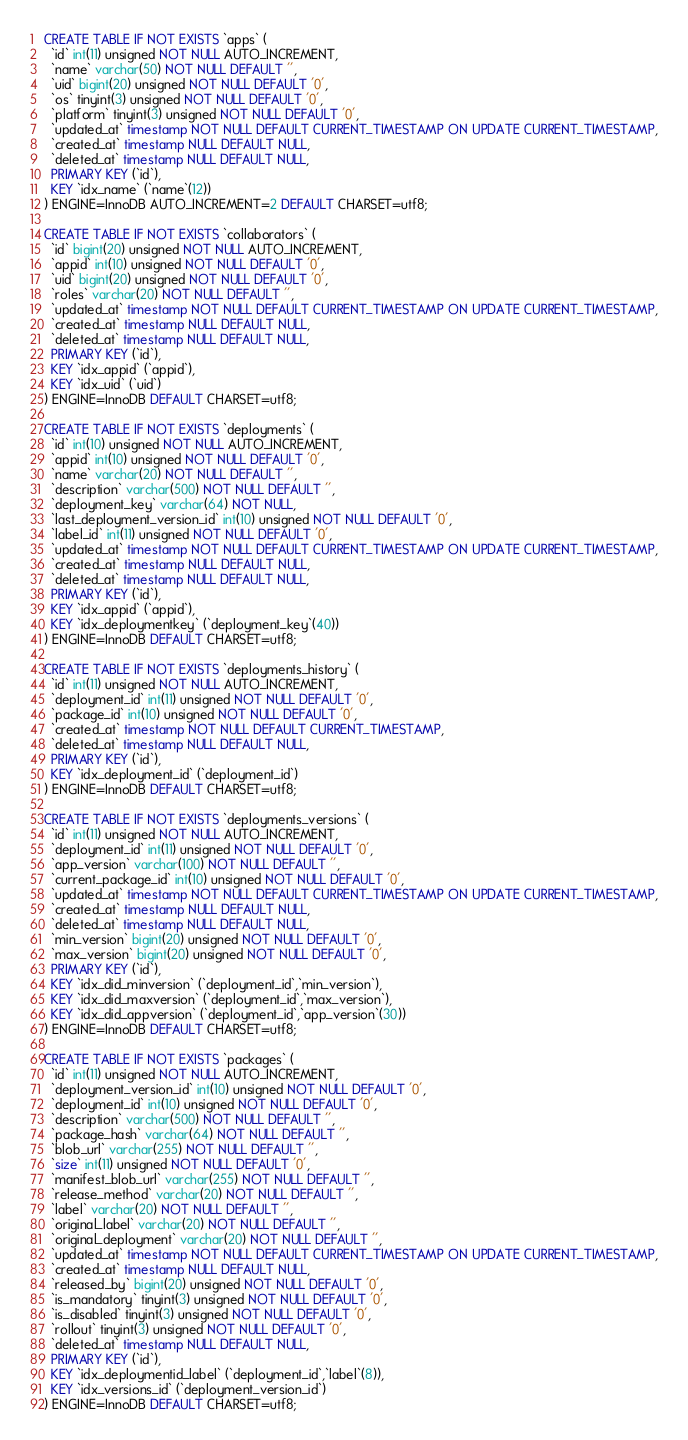Convert code to text. <code><loc_0><loc_0><loc_500><loc_500><_SQL_>CREATE TABLE IF NOT EXISTS `apps` (
  `id` int(11) unsigned NOT NULL AUTO_INCREMENT,
  `name` varchar(50) NOT NULL DEFAULT '',
  `uid` bigint(20) unsigned NOT NULL DEFAULT '0',
  `os` tinyint(3) unsigned NOT NULL DEFAULT '0',
  `platform` tinyint(3) unsigned NOT NULL DEFAULT '0',
  `updated_at` timestamp NOT NULL DEFAULT CURRENT_TIMESTAMP ON UPDATE CURRENT_TIMESTAMP,
  `created_at` timestamp NULL DEFAULT NULL,
  `deleted_at` timestamp NULL DEFAULT NULL,
  PRIMARY KEY (`id`),
  KEY `idx_name` (`name`(12))
) ENGINE=InnoDB AUTO_INCREMENT=2 DEFAULT CHARSET=utf8;

CREATE TABLE IF NOT EXISTS `collaborators` (
  `id` bigint(20) unsigned NOT NULL AUTO_INCREMENT,
  `appid` int(10) unsigned NOT NULL DEFAULT '0',
  `uid` bigint(20) unsigned NOT NULL DEFAULT '0',
  `roles` varchar(20) NOT NULL DEFAULT '',
  `updated_at` timestamp NOT NULL DEFAULT CURRENT_TIMESTAMP ON UPDATE CURRENT_TIMESTAMP,
  `created_at` timestamp NULL DEFAULT NULL,
  `deleted_at` timestamp NULL DEFAULT NULL,
  PRIMARY KEY (`id`),
  KEY `idx_appid` (`appid`),
  KEY `idx_uid` (`uid`)
) ENGINE=InnoDB DEFAULT CHARSET=utf8;

CREATE TABLE IF NOT EXISTS `deployments` (
  `id` int(10) unsigned NOT NULL AUTO_INCREMENT,
  `appid` int(10) unsigned NOT NULL DEFAULT '0',
  `name` varchar(20) NOT NULL DEFAULT '',
  `description` varchar(500) NOT NULL DEFAULT '',
  `deployment_key` varchar(64) NOT NULL,
  `last_deployment_version_id` int(10) unsigned NOT NULL DEFAULT '0',
  `label_id` int(11) unsigned NOT NULL DEFAULT '0',
  `updated_at` timestamp NOT NULL DEFAULT CURRENT_TIMESTAMP ON UPDATE CURRENT_TIMESTAMP,
  `created_at` timestamp NULL DEFAULT NULL,
  `deleted_at` timestamp NULL DEFAULT NULL,
  PRIMARY KEY (`id`),
  KEY `idx_appid` (`appid`),
  KEY `idx_deploymentkey` (`deployment_key`(40))
) ENGINE=InnoDB DEFAULT CHARSET=utf8;

CREATE TABLE IF NOT EXISTS `deployments_history` (
  `id` int(11) unsigned NOT NULL AUTO_INCREMENT,
  `deployment_id` int(11) unsigned NOT NULL DEFAULT '0',
  `package_id` int(10) unsigned NOT NULL DEFAULT '0',
  `created_at` timestamp NOT NULL DEFAULT CURRENT_TIMESTAMP,
  `deleted_at` timestamp NULL DEFAULT NULL,
  PRIMARY KEY (`id`),
  KEY `idx_deployment_id` (`deployment_id`)
) ENGINE=InnoDB DEFAULT CHARSET=utf8;

CREATE TABLE IF NOT EXISTS `deployments_versions` (
  `id` int(11) unsigned NOT NULL AUTO_INCREMENT,
  `deployment_id` int(11) unsigned NOT NULL DEFAULT '0',
  `app_version` varchar(100) NOT NULL DEFAULT '',
  `current_package_id` int(10) unsigned NOT NULL DEFAULT '0',
  `updated_at` timestamp NOT NULL DEFAULT CURRENT_TIMESTAMP ON UPDATE CURRENT_TIMESTAMP,
  `created_at` timestamp NULL DEFAULT NULL,
  `deleted_at` timestamp NULL DEFAULT NULL,
  `min_version` bigint(20) unsigned NOT NULL DEFAULT '0',
  `max_version` bigint(20) unsigned NOT NULL DEFAULT '0',
  PRIMARY KEY (`id`),
  KEY `idx_did_minversion` (`deployment_id`,`min_version`),
  KEY `idx_did_maxversion` (`deployment_id`,`max_version`),
  KEY `idx_did_appversion` (`deployment_id`,`app_version`(30))
) ENGINE=InnoDB DEFAULT CHARSET=utf8;

CREATE TABLE IF NOT EXISTS `packages` (
  `id` int(11) unsigned NOT NULL AUTO_INCREMENT,
  `deployment_version_id` int(10) unsigned NOT NULL DEFAULT '0',
  `deployment_id` int(10) unsigned NOT NULL DEFAULT '0',
  `description` varchar(500) NOT NULL DEFAULT '',
  `package_hash` varchar(64) NOT NULL DEFAULT '',
  `blob_url` varchar(255) NOT NULL DEFAULT '',
  `size` int(11) unsigned NOT NULL DEFAULT '0',
  `manifest_blob_url` varchar(255) NOT NULL DEFAULT '',
  `release_method` varchar(20) NOT NULL DEFAULT '',
  `label` varchar(20) NOT NULL DEFAULT '',
  `original_label` varchar(20) NOT NULL DEFAULT '',
  `original_deployment` varchar(20) NOT NULL DEFAULT '',
  `updated_at` timestamp NOT NULL DEFAULT CURRENT_TIMESTAMP ON UPDATE CURRENT_TIMESTAMP,
  `created_at` timestamp NULL DEFAULT NULL,
  `released_by` bigint(20) unsigned NOT NULL DEFAULT '0',
  `is_mandatory` tinyint(3) unsigned NOT NULL DEFAULT '0',
  `is_disabled` tinyint(3) unsigned NOT NULL DEFAULT '0',
  `rollout` tinyint(3) unsigned NOT NULL DEFAULT '0',
  `deleted_at` timestamp NULL DEFAULT NULL,
  PRIMARY KEY (`id`),
  KEY `idx_deploymentid_label` (`deployment_id`,`label`(8)),
  KEY `idx_versions_id` (`deployment_version_id`)
) ENGINE=InnoDB DEFAULT CHARSET=utf8;
</code> 